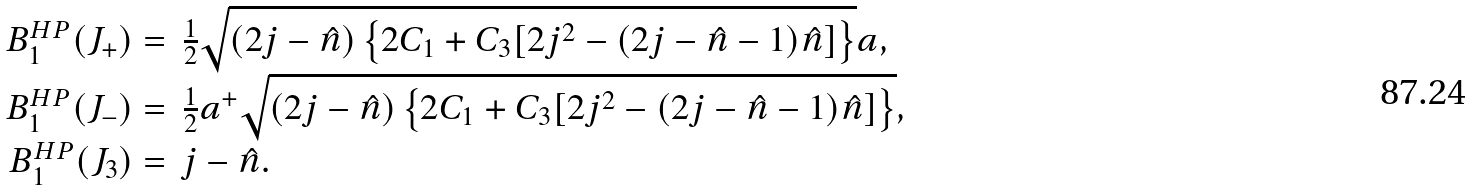Convert formula to latex. <formula><loc_0><loc_0><loc_500><loc_500>\begin{array} { r l } B _ { 1 } ^ { H P } ( J _ { + } ) = & \frac { 1 } { 2 } \sqrt { ( 2 j - \hat { n } ) \left \{ 2 C _ { 1 } + C _ { 3 } [ 2 j ^ { 2 } - ( 2 j - \hat { n } - 1 ) \hat { n } ] \right \} } a , \\ B _ { 1 } ^ { H P } ( J _ { - } ) = & \frac { 1 } { 2 } a ^ { + } \sqrt { ( 2 j - \hat { n } ) \left \{ 2 C _ { 1 } + C _ { 3 } [ 2 j ^ { 2 } - ( 2 j - \hat { n } - 1 ) \hat { n } ] \right \} } , \\ B _ { 1 } ^ { H P } ( J _ { 3 } ) = & j - \hat { n } . \end{array}</formula> 